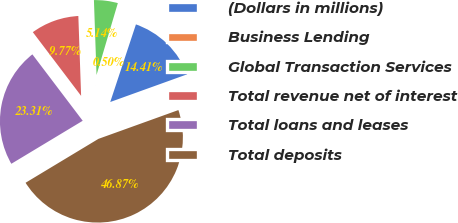Convert chart. <chart><loc_0><loc_0><loc_500><loc_500><pie_chart><fcel>(Dollars in millions)<fcel>Business Lending<fcel>Global Transaction Services<fcel>Total revenue net of interest<fcel>Total loans and leases<fcel>Total deposits<nl><fcel>14.41%<fcel>0.5%<fcel>5.14%<fcel>9.77%<fcel>23.31%<fcel>46.87%<nl></chart> 